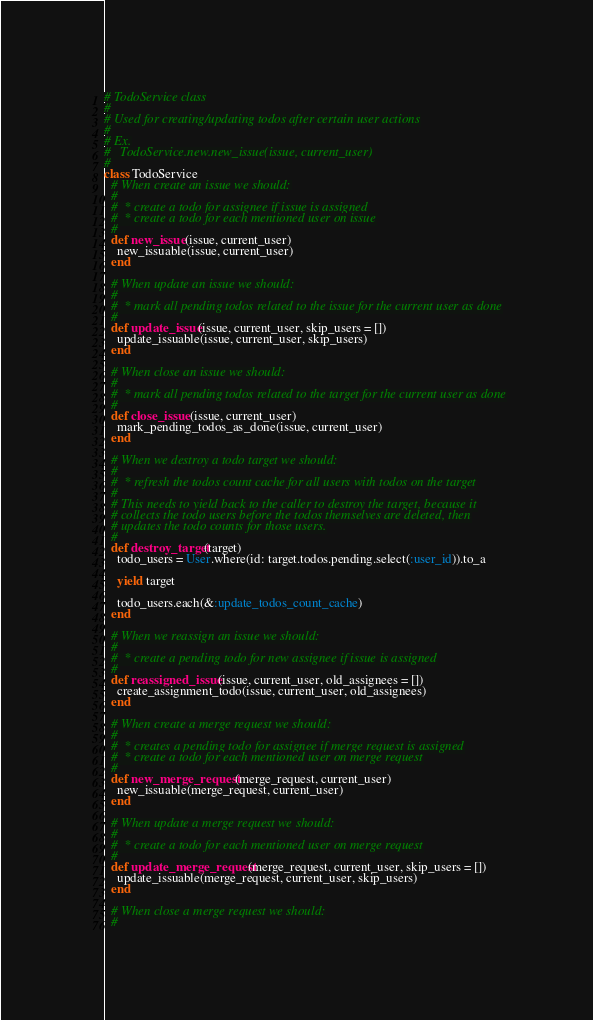<code> <loc_0><loc_0><loc_500><loc_500><_Ruby_># TodoService class
#
# Used for creating/updating todos after certain user actions
#
# Ex.
#   TodoService.new.new_issue(issue, current_user)
#
class TodoService
  # When create an issue we should:
  #
  #  * create a todo for assignee if issue is assigned
  #  * create a todo for each mentioned user on issue
  #
  def new_issue(issue, current_user)
    new_issuable(issue, current_user)
  end

  # When update an issue we should:
  #
  #  * mark all pending todos related to the issue for the current user as done
  #
  def update_issue(issue, current_user, skip_users = [])
    update_issuable(issue, current_user, skip_users)
  end

  # When close an issue we should:
  #
  #  * mark all pending todos related to the target for the current user as done
  #
  def close_issue(issue, current_user)
    mark_pending_todos_as_done(issue, current_user)
  end

  # When we destroy a todo target we should:
  #
  #  * refresh the todos count cache for all users with todos on the target
  #
  # This needs to yield back to the caller to destroy the target, because it
  # collects the todo users before the todos themselves are deleted, then
  # updates the todo counts for those users.
  #
  def destroy_target(target)
    todo_users = User.where(id: target.todos.pending.select(:user_id)).to_a

    yield target

    todo_users.each(&:update_todos_count_cache)
  end

  # When we reassign an issue we should:
  #
  #  * create a pending todo for new assignee if issue is assigned
  #
  def reassigned_issue(issue, current_user, old_assignees = [])
    create_assignment_todo(issue, current_user, old_assignees)
  end

  # When create a merge request we should:
  #
  #  * creates a pending todo for assignee if merge request is assigned
  #  * create a todo for each mentioned user on merge request
  #
  def new_merge_request(merge_request, current_user)
    new_issuable(merge_request, current_user)
  end

  # When update a merge request we should:
  #
  #  * create a todo for each mentioned user on merge request
  #
  def update_merge_request(merge_request, current_user, skip_users = [])
    update_issuable(merge_request, current_user, skip_users)
  end

  # When close a merge request we should:
  #</code> 